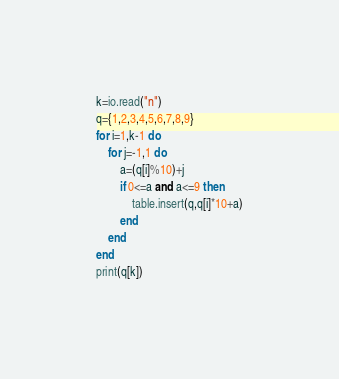Convert code to text. <code><loc_0><loc_0><loc_500><loc_500><_Lua_>k=io.read("n")
q={1,2,3,4,5,6,7,8,9}
for i=1,k-1 do
    for j=-1,1 do
        a=(q[i]%10)+j
        if 0<=a and a<=9 then
            table.insert(q,q[i]*10+a)
        end
    end
end
print(q[k])</code> 